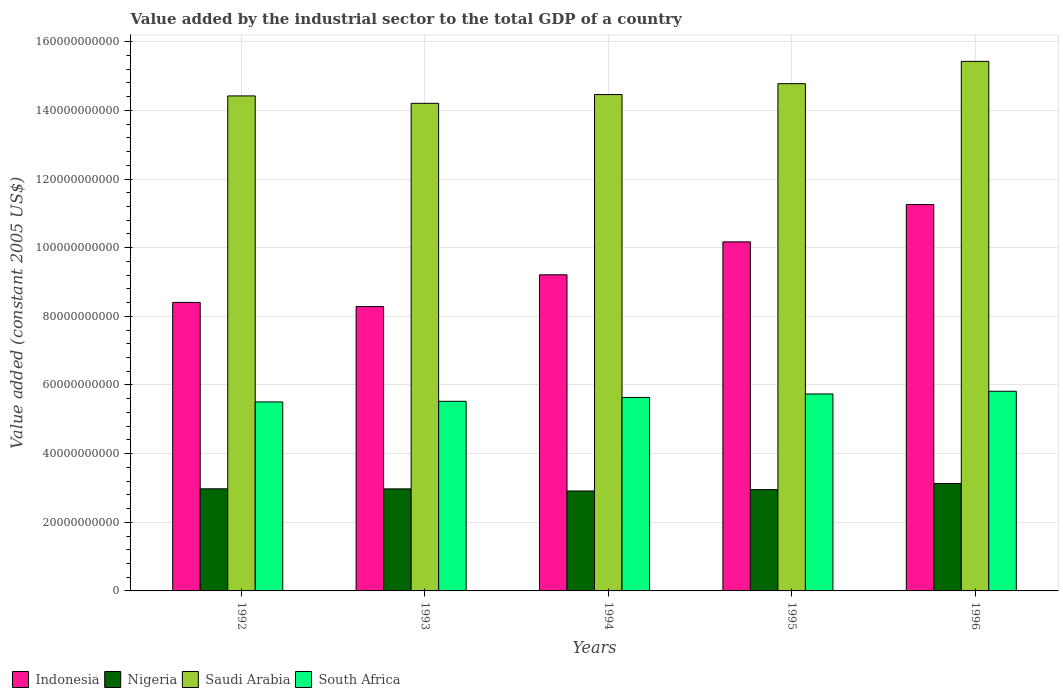How many different coloured bars are there?
Offer a terse response. 4. How many groups of bars are there?
Make the answer very short. 5. Are the number of bars per tick equal to the number of legend labels?
Provide a succinct answer. Yes. Are the number of bars on each tick of the X-axis equal?
Your answer should be very brief. Yes. In how many cases, is the number of bars for a given year not equal to the number of legend labels?
Keep it short and to the point. 0. What is the value added by the industrial sector in Indonesia in 1993?
Provide a succinct answer. 8.29e+1. Across all years, what is the maximum value added by the industrial sector in Nigeria?
Offer a terse response. 3.13e+1. Across all years, what is the minimum value added by the industrial sector in Nigeria?
Ensure brevity in your answer.  2.91e+1. In which year was the value added by the industrial sector in Saudi Arabia minimum?
Offer a terse response. 1993. What is the total value added by the industrial sector in South Africa in the graph?
Give a very brief answer. 2.82e+11. What is the difference between the value added by the industrial sector in Indonesia in 1992 and that in 1994?
Ensure brevity in your answer.  -8.05e+09. What is the difference between the value added by the industrial sector in Nigeria in 1992 and the value added by the industrial sector in Saudi Arabia in 1993?
Make the answer very short. -1.12e+11. What is the average value added by the industrial sector in Indonesia per year?
Your answer should be compact. 9.47e+1. In the year 1992, what is the difference between the value added by the industrial sector in Saudi Arabia and value added by the industrial sector in South Africa?
Your response must be concise. 8.92e+1. In how many years, is the value added by the industrial sector in South Africa greater than 44000000000 US$?
Your answer should be very brief. 5. What is the ratio of the value added by the industrial sector in Saudi Arabia in 1992 to that in 1993?
Your response must be concise. 1.02. Is the value added by the industrial sector in Indonesia in 1993 less than that in 1994?
Your answer should be compact. Yes. What is the difference between the highest and the second highest value added by the industrial sector in Indonesia?
Your response must be concise. 1.09e+1. What is the difference between the highest and the lowest value added by the industrial sector in Indonesia?
Provide a succinct answer. 2.97e+1. Is the sum of the value added by the industrial sector in South Africa in 1993 and 1994 greater than the maximum value added by the industrial sector in Nigeria across all years?
Provide a succinct answer. Yes. What does the 1st bar from the right in 1992 represents?
Give a very brief answer. South Africa. Is it the case that in every year, the sum of the value added by the industrial sector in South Africa and value added by the industrial sector in Nigeria is greater than the value added by the industrial sector in Indonesia?
Offer a very short reply. No. How many years are there in the graph?
Give a very brief answer. 5. What is the difference between two consecutive major ticks on the Y-axis?
Offer a terse response. 2.00e+1. Are the values on the major ticks of Y-axis written in scientific E-notation?
Give a very brief answer. No. Does the graph contain grids?
Your response must be concise. Yes. How many legend labels are there?
Your answer should be compact. 4. What is the title of the graph?
Offer a very short reply. Value added by the industrial sector to the total GDP of a country. What is the label or title of the Y-axis?
Make the answer very short. Value added (constant 2005 US$). What is the Value added (constant 2005 US$) in Indonesia in 1992?
Your response must be concise. 8.41e+1. What is the Value added (constant 2005 US$) of Nigeria in 1992?
Keep it short and to the point. 2.97e+1. What is the Value added (constant 2005 US$) of Saudi Arabia in 1992?
Make the answer very short. 1.44e+11. What is the Value added (constant 2005 US$) of South Africa in 1992?
Give a very brief answer. 5.51e+1. What is the Value added (constant 2005 US$) in Indonesia in 1993?
Your answer should be compact. 8.29e+1. What is the Value added (constant 2005 US$) in Nigeria in 1993?
Offer a terse response. 2.97e+1. What is the Value added (constant 2005 US$) of Saudi Arabia in 1993?
Give a very brief answer. 1.42e+11. What is the Value added (constant 2005 US$) in South Africa in 1993?
Offer a very short reply. 5.53e+1. What is the Value added (constant 2005 US$) of Indonesia in 1994?
Offer a terse response. 9.21e+1. What is the Value added (constant 2005 US$) of Nigeria in 1994?
Offer a terse response. 2.91e+1. What is the Value added (constant 2005 US$) of Saudi Arabia in 1994?
Provide a succinct answer. 1.45e+11. What is the Value added (constant 2005 US$) in South Africa in 1994?
Ensure brevity in your answer.  5.64e+1. What is the Value added (constant 2005 US$) in Indonesia in 1995?
Provide a succinct answer. 1.02e+11. What is the Value added (constant 2005 US$) in Nigeria in 1995?
Offer a terse response. 2.95e+1. What is the Value added (constant 2005 US$) of Saudi Arabia in 1995?
Offer a terse response. 1.48e+11. What is the Value added (constant 2005 US$) in South Africa in 1995?
Offer a very short reply. 5.74e+1. What is the Value added (constant 2005 US$) in Indonesia in 1996?
Your answer should be very brief. 1.13e+11. What is the Value added (constant 2005 US$) of Nigeria in 1996?
Give a very brief answer. 3.13e+1. What is the Value added (constant 2005 US$) of Saudi Arabia in 1996?
Your response must be concise. 1.54e+11. What is the Value added (constant 2005 US$) of South Africa in 1996?
Give a very brief answer. 5.82e+1. Across all years, what is the maximum Value added (constant 2005 US$) in Indonesia?
Offer a terse response. 1.13e+11. Across all years, what is the maximum Value added (constant 2005 US$) in Nigeria?
Ensure brevity in your answer.  3.13e+1. Across all years, what is the maximum Value added (constant 2005 US$) of Saudi Arabia?
Keep it short and to the point. 1.54e+11. Across all years, what is the maximum Value added (constant 2005 US$) in South Africa?
Your answer should be very brief. 5.82e+1. Across all years, what is the minimum Value added (constant 2005 US$) of Indonesia?
Your answer should be compact. 8.29e+1. Across all years, what is the minimum Value added (constant 2005 US$) in Nigeria?
Provide a short and direct response. 2.91e+1. Across all years, what is the minimum Value added (constant 2005 US$) in Saudi Arabia?
Give a very brief answer. 1.42e+11. Across all years, what is the minimum Value added (constant 2005 US$) of South Africa?
Give a very brief answer. 5.51e+1. What is the total Value added (constant 2005 US$) in Indonesia in the graph?
Offer a terse response. 4.73e+11. What is the total Value added (constant 2005 US$) of Nigeria in the graph?
Give a very brief answer. 1.49e+11. What is the total Value added (constant 2005 US$) in Saudi Arabia in the graph?
Your answer should be very brief. 7.33e+11. What is the total Value added (constant 2005 US$) of South Africa in the graph?
Keep it short and to the point. 2.82e+11. What is the difference between the Value added (constant 2005 US$) of Indonesia in 1992 and that in 1993?
Offer a very short reply. 1.21e+09. What is the difference between the Value added (constant 2005 US$) of Nigeria in 1992 and that in 1993?
Your answer should be very brief. 1.50e+07. What is the difference between the Value added (constant 2005 US$) of Saudi Arabia in 1992 and that in 1993?
Provide a short and direct response. 2.16e+09. What is the difference between the Value added (constant 2005 US$) in South Africa in 1992 and that in 1993?
Your answer should be very brief. -1.92e+08. What is the difference between the Value added (constant 2005 US$) of Indonesia in 1992 and that in 1994?
Offer a very short reply. -8.05e+09. What is the difference between the Value added (constant 2005 US$) in Nigeria in 1992 and that in 1994?
Keep it short and to the point. 6.24e+08. What is the difference between the Value added (constant 2005 US$) in Saudi Arabia in 1992 and that in 1994?
Give a very brief answer. -3.95e+08. What is the difference between the Value added (constant 2005 US$) in South Africa in 1992 and that in 1994?
Your answer should be compact. -1.31e+09. What is the difference between the Value added (constant 2005 US$) of Indonesia in 1992 and that in 1995?
Your response must be concise. -1.76e+1. What is the difference between the Value added (constant 2005 US$) in Nigeria in 1992 and that in 1995?
Your response must be concise. 2.28e+08. What is the difference between the Value added (constant 2005 US$) of Saudi Arabia in 1992 and that in 1995?
Make the answer very short. -3.56e+09. What is the difference between the Value added (constant 2005 US$) of South Africa in 1992 and that in 1995?
Ensure brevity in your answer.  -2.33e+09. What is the difference between the Value added (constant 2005 US$) in Indonesia in 1992 and that in 1996?
Provide a short and direct response. -2.85e+1. What is the difference between the Value added (constant 2005 US$) in Nigeria in 1992 and that in 1996?
Keep it short and to the point. -1.55e+09. What is the difference between the Value added (constant 2005 US$) in Saudi Arabia in 1992 and that in 1996?
Offer a terse response. -1.01e+1. What is the difference between the Value added (constant 2005 US$) of South Africa in 1992 and that in 1996?
Provide a short and direct response. -3.12e+09. What is the difference between the Value added (constant 2005 US$) in Indonesia in 1993 and that in 1994?
Ensure brevity in your answer.  -9.25e+09. What is the difference between the Value added (constant 2005 US$) of Nigeria in 1993 and that in 1994?
Offer a terse response. 6.09e+08. What is the difference between the Value added (constant 2005 US$) in Saudi Arabia in 1993 and that in 1994?
Offer a very short reply. -2.55e+09. What is the difference between the Value added (constant 2005 US$) of South Africa in 1993 and that in 1994?
Offer a very short reply. -1.12e+09. What is the difference between the Value added (constant 2005 US$) of Indonesia in 1993 and that in 1995?
Offer a terse response. -1.89e+1. What is the difference between the Value added (constant 2005 US$) in Nigeria in 1993 and that in 1995?
Offer a terse response. 2.13e+08. What is the difference between the Value added (constant 2005 US$) of Saudi Arabia in 1993 and that in 1995?
Keep it short and to the point. -5.72e+09. What is the difference between the Value added (constant 2005 US$) in South Africa in 1993 and that in 1995?
Give a very brief answer. -2.14e+09. What is the difference between the Value added (constant 2005 US$) of Indonesia in 1993 and that in 1996?
Give a very brief answer. -2.97e+1. What is the difference between the Value added (constant 2005 US$) of Nigeria in 1993 and that in 1996?
Ensure brevity in your answer.  -1.57e+09. What is the difference between the Value added (constant 2005 US$) of Saudi Arabia in 1993 and that in 1996?
Make the answer very short. -1.22e+1. What is the difference between the Value added (constant 2005 US$) in South Africa in 1993 and that in 1996?
Keep it short and to the point. -2.93e+09. What is the difference between the Value added (constant 2005 US$) of Indonesia in 1994 and that in 1995?
Offer a very short reply. -9.60e+09. What is the difference between the Value added (constant 2005 US$) of Nigeria in 1994 and that in 1995?
Give a very brief answer. -3.96e+08. What is the difference between the Value added (constant 2005 US$) of Saudi Arabia in 1994 and that in 1995?
Ensure brevity in your answer.  -3.17e+09. What is the difference between the Value added (constant 2005 US$) in South Africa in 1994 and that in 1995?
Ensure brevity in your answer.  -1.02e+09. What is the difference between the Value added (constant 2005 US$) of Indonesia in 1994 and that in 1996?
Provide a short and direct response. -2.05e+1. What is the difference between the Value added (constant 2005 US$) in Nigeria in 1994 and that in 1996?
Give a very brief answer. -2.17e+09. What is the difference between the Value added (constant 2005 US$) in Saudi Arabia in 1994 and that in 1996?
Give a very brief answer. -9.67e+09. What is the difference between the Value added (constant 2005 US$) of South Africa in 1994 and that in 1996?
Your answer should be very brief. -1.81e+09. What is the difference between the Value added (constant 2005 US$) of Indonesia in 1995 and that in 1996?
Your answer should be very brief. -1.09e+1. What is the difference between the Value added (constant 2005 US$) of Nigeria in 1995 and that in 1996?
Make the answer very short. -1.78e+09. What is the difference between the Value added (constant 2005 US$) in Saudi Arabia in 1995 and that in 1996?
Your response must be concise. -6.50e+09. What is the difference between the Value added (constant 2005 US$) in South Africa in 1995 and that in 1996?
Your answer should be very brief. -7.94e+08. What is the difference between the Value added (constant 2005 US$) in Indonesia in 1992 and the Value added (constant 2005 US$) in Nigeria in 1993?
Your answer should be very brief. 5.43e+1. What is the difference between the Value added (constant 2005 US$) of Indonesia in 1992 and the Value added (constant 2005 US$) of Saudi Arabia in 1993?
Provide a short and direct response. -5.80e+1. What is the difference between the Value added (constant 2005 US$) in Indonesia in 1992 and the Value added (constant 2005 US$) in South Africa in 1993?
Offer a terse response. 2.88e+1. What is the difference between the Value added (constant 2005 US$) of Nigeria in 1992 and the Value added (constant 2005 US$) of Saudi Arabia in 1993?
Your answer should be very brief. -1.12e+11. What is the difference between the Value added (constant 2005 US$) of Nigeria in 1992 and the Value added (constant 2005 US$) of South Africa in 1993?
Keep it short and to the point. -2.55e+1. What is the difference between the Value added (constant 2005 US$) of Saudi Arabia in 1992 and the Value added (constant 2005 US$) of South Africa in 1993?
Provide a short and direct response. 8.90e+1. What is the difference between the Value added (constant 2005 US$) of Indonesia in 1992 and the Value added (constant 2005 US$) of Nigeria in 1994?
Make the answer very short. 5.49e+1. What is the difference between the Value added (constant 2005 US$) of Indonesia in 1992 and the Value added (constant 2005 US$) of Saudi Arabia in 1994?
Offer a very short reply. -6.06e+1. What is the difference between the Value added (constant 2005 US$) in Indonesia in 1992 and the Value added (constant 2005 US$) in South Africa in 1994?
Give a very brief answer. 2.77e+1. What is the difference between the Value added (constant 2005 US$) in Nigeria in 1992 and the Value added (constant 2005 US$) in Saudi Arabia in 1994?
Your answer should be very brief. -1.15e+11. What is the difference between the Value added (constant 2005 US$) of Nigeria in 1992 and the Value added (constant 2005 US$) of South Africa in 1994?
Make the answer very short. -2.66e+1. What is the difference between the Value added (constant 2005 US$) of Saudi Arabia in 1992 and the Value added (constant 2005 US$) of South Africa in 1994?
Keep it short and to the point. 8.79e+1. What is the difference between the Value added (constant 2005 US$) in Indonesia in 1992 and the Value added (constant 2005 US$) in Nigeria in 1995?
Provide a short and direct response. 5.45e+1. What is the difference between the Value added (constant 2005 US$) of Indonesia in 1992 and the Value added (constant 2005 US$) of Saudi Arabia in 1995?
Your response must be concise. -6.37e+1. What is the difference between the Value added (constant 2005 US$) in Indonesia in 1992 and the Value added (constant 2005 US$) in South Africa in 1995?
Provide a short and direct response. 2.67e+1. What is the difference between the Value added (constant 2005 US$) in Nigeria in 1992 and the Value added (constant 2005 US$) in Saudi Arabia in 1995?
Give a very brief answer. -1.18e+11. What is the difference between the Value added (constant 2005 US$) in Nigeria in 1992 and the Value added (constant 2005 US$) in South Africa in 1995?
Ensure brevity in your answer.  -2.76e+1. What is the difference between the Value added (constant 2005 US$) of Saudi Arabia in 1992 and the Value added (constant 2005 US$) of South Africa in 1995?
Your answer should be very brief. 8.68e+1. What is the difference between the Value added (constant 2005 US$) in Indonesia in 1992 and the Value added (constant 2005 US$) in Nigeria in 1996?
Your answer should be compact. 5.28e+1. What is the difference between the Value added (constant 2005 US$) of Indonesia in 1992 and the Value added (constant 2005 US$) of Saudi Arabia in 1996?
Ensure brevity in your answer.  -7.02e+1. What is the difference between the Value added (constant 2005 US$) of Indonesia in 1992 and the Value added (constant 2005 US$) of South Africa in 1996?
Give a very brief answer. 2.59e+1. What is the difference between the Value added (constant 2005 US$) in Nigeria in 1992 and the Value added (constant 2005 US$) in Saudi Arabia in 1996?
Keep it short and to the point. -1.25e+11. What is the difference between the Value added (constant 2005 US$) of Nigeria in 1992 and the Value added (constant 2005 US$) of South Africa in 1996?
Ensure brevity in your answer.  -2.84e+1. What is the difference between the Value added (constant 2005 US$) in Saudi Arabia in 1992 and the Value added (constant 2005 US$) in South Africa in 1996?
Make the answer very short. 8.60e+1. What is the difference between the Value added (constant 2005 US$) in Indonesia in 1993 and the Value added (constant 2005 US$) in Nigeria in 1994?
Keep it short and to the point. 5.37e+1. What is the difference between the Value added (constant 2005 US$) in Indonesia in 1993 and the Value added (constant 2005 US$) in Saudi Arabia in 1994?
Your response must be concise. -6.18e+1. What is the difference between the Value added (constant 2005 US$) in Indonesia in 1993 and the Value added (constant 2005 US$) in South Africa in 1994?
Your response must be concise. 2.65e+1. What is the difference between the Value added (constant 2005 US$) of Nigeria in 1993 and the Value added (constant 2005 US$) of Saudi Arabia in 1994?
Keep it short and to the point. -1.15e+11. What is the difference between the Value added (constant 2005 US$) in Nigeria in 1993 and the Value added (constant 2005 US$) in South Africa in 1994?
Provide a short and direct response. -2.66e+1. What is the difference between the Value added (constant 2005 US$) of Saudi Arabia in 1993 and the Value added (constant 2005 US$) of South Africa in 1994?
Ensure brevity in your answer.  8.57e+1. What is the difference between the Value added (constant 2005 US$) of Indonesia in 1993 and the Value added (constant 2005 US$) of Nigeria in 1995?
Provide a succinct answer. 5.33e+1. What is the difference between the Value added (constant 2005 US$) in Indonesia in 1993 and the Value added (constant 2005 US$) in Saudi Arabia in 1995?
Keep it short and to the point. -6.49e+1. What is the difference between the Value added (constant 2005 US$) of Indonesia in 1993 and the Value added (constant 2005 US$) of South Africa in 1995?
Provide a succinct answer. 2.55e+1. What is the difference between the Value added (constant 2005 US$) in Nigeria in 1993 and the Value added (constant 2005 US$) in Saudi Arabia in 1995?
Your answer should be very brief. -1.18e+11. What is the difference between the Value added (constant 2005 US$) in Nigeria in 1993 and the Value added (constant 2005 US$) in South Africa in 1995?
Provide a succinct answer. -2.77e+1. What is the difference between the Value added (constant 2005 US$) of Saudi Arabia in 1993 and the Value added (constant 2005 US$) of South Africa in 1995?
Make the answer very short. 8.47e+1. What is the difference between the Value added (constant 2005 US$) in Indonesia in 1993 and the Value added (constant 2005 US$) in Nigeria in 1996?
Provide a short and direct response. 5.16e+1. What is the difference between the Value added (constant 2005 US$) in Indonesia in 1993 and the Value added (constant 2005 US$) in Saudi Arabia in 1996?
Give a very brief answer. -7.14e+1. What is the difference between the Value added (constant 2005 US$) of Indonesia in 1993 and the Value added (constant 2005 US$) of South Africa in 1996?
Provide a succinct answer. 2.47e+1. What is the difference between the Value added (constant 2005 US$) of Nigeria in 1993 and the Value added (constant 2005 US$) of Saudi Arabia in 1996?
Your answer should be very brief. -1.25e+11. What is the difference between the Value added (constant 2005 US$) of Nigeria in 1993 and the Value added (constant 2005 US$) of South Africa in 1996?
Provide a short and direct response. -2.84e+1. What is the difference between the Value added (constant 2005 US$) of Saudi Arabia in 1993 and the Value added (constant 2005 US$) of South Africa in 1996?
Ensure brevity in your answer.  8.39e+1. What is the difference between the Value added (constant 2005 US$) in Indonesia in 1994 and the Value added (constant 2005 US$) in Nigeria in 1995?
Offer a terse response. 6.26e+1. What is the difference between the Value added (constant 2005 US$) of Indonesia in 1994 and the Value added (constant 2005 US$) of Saudi Arabia in 1995?
Your answer should be compact. -5.57e+1. What is the difference between the Value added (constant 2005 US$) of Indonesia in 1994 and the Value added (constant 2005 US$) of South Africa in 1995?
Offer a terse response. 3.47e+1. What is the difference between the Value added (constant 2005 US$) in Nigeria in 1994 and the Value added (constant 2005 US$) in Saudi Arabia in 1995?
Make the answer very short. -1.19e+11. What is the difference between the Value added (constant 2005 US$) in Nigeria in 1994 and the Value added (constant 2005 US$) in South Africa in 1995?
Your response must be concise. -2.83e+1. What is the difference between the Value added (constant 2005 US$) in Saudi Arabia in 1994 and the Value added (constant 2005 US$) in South Africa in 1995?
Keep it short and to the point. 8.72e+1. What is the difference between the Value added (constant 2005 US$) in Indonesia in 1994 and the Value added (constant 2005 US$) in Nigeria in 1996?
Your response must be concise. 6.08e+1. What is the difference between the Value added (constant 2005 US$) of Indonesia in 1994 and the Value added (constant 2005 US$) of Saudi Arabia in 1996?
Offer a terse response. -6.22e+1. What is the difference between the Value added (constant 2005 US$) of Indonesia in 1994 and the Value added (constant 2005 US$) of South Africa in 1996?
Ensure brevity in your answer.  3.39e+1. What is the difference between the Value added (constant 2005 US$) in Nigeria in 1994 and the Value added (constant 2005 US$) in Saudi Arabia in 1996?
Your answer should be very brief. -1.25e+11. What is the difference between the Value added (constant 2005 US$) in Nigeria in 1994 and the Value added (constant 2005 US$) in South Africa in 1996?
Give a very brief answer. -2.91e+1. What is the difference between the Value added (constant 2005 US$) of Saudi Arabia in 1994 and the Value added (constant 2005 US$) of South Africa in 1996?
Ensure brevity in your answer.  8.64e+1. What is the difference between the Value added (constant 2005 US$) of Indonesia in 1995 and the Value added (constant 2005 US$) of Nigeria in 1996?
Provide a short and direct response. 7.04e+1. What is the difference between the Value added (constant 2005 US$) of Indonesia in 1995 and the Value added (constant 2005 US$) of Saudi Arabia in 1996?
Offer a very short reply. -5.26e+1. What is the difference between the Value added (constant 2005 US$) of Indonesia in 1995 and the Value added (constant 2005 US$) of South Africa in 1996?
Offer a very short reply. 4.35e+1. What is the difference between the Value added (constant 2005 US$) of Nigeria in 1995 and the Value added (constant 2005 US$) of Saudi Arabia in 1996?
Keep it short and to the point. -1.25e+11. What is the difference between the Value added (constant 2005 US$) in Nigeria in 1995 and the Value added (constant 2005 US$) in South Africa in 1996?
Provide a short and direct response. -2.87e+1. What is the difference between the Value added (constant 2005 US$) of Saudi Arabia in 1995 and the Value added (constant 2005 US$) of South Africa in 1996?
Give a very brief answer. 8.96e+1. What is the average Value added (constant 2005 US$) of Indonesia per year?
Provide a short and direct response. 9.47e+1. What is the average Value added (constant 2005 US$) of Nigeria per year?
Provide a succinct answer. 2.99e+1. What is the average Value added (constant 2005 US$) in Saudi Arabia per year?
Keep it short and to the point. 1.47e+11. What is the average Value added (constant 2005 US$) of South Africa per year?
Provide a short and direct response. 5.64e+1. In the year 1992, what is the difference between the Value added (constant 2005 US$) in Indonesia and Value added (constant 2005 US$) in Nigeria?
Your response must be concise. 5.43e+1. In the year 1992, what is the difference between the Value added (constant 2005 US$) of Indonesia and Value added (constant 2005 US$) of Saudi Arabia?
Give a very brief answer. -6.02e+1. In the year 1992, what is the difference between the Value added (constant 2005 US$) in Indonesia and Value added (constant 2005 US$) in South Africa?
Provide a short and direct response. 2.90e+1. In the year 1992, what is the difference between the Value added (constant 2005 US$) of Nigeria and Value added (constant 2005 US$) of Saudi Arabia?
Provide a succinct answer. -1.14e+11. In the year 1992, what is the difference between the Value added (constant 2005 US$) of Nigeria and Value added (constant 2005 US$) of South Africa?
Your response must be concise. -2.53e+1. In the year 1992, what is the difference between the Value added (constant 2005 US$) in Saudi Arabia and Value added (constant 2005 US$) in South Africa?
Provide a short and direct response. 8.92e+1. In the year 1993, what is the difference between the Value added (constant 2005 US$) of Indonesia and Value added (constant 2005 US$) of Nigeria?
Provide a succinct answer. 5.31e+1. In the year 1993, what is the difference between the Value added (constant 2005 US$) of Indonesia and Value added (constant 2005 US$) of Saudi Arabia?
Keep it short and to the point. -5.92e+1. In the year 1993, what is the difference between the Value added (constant 2005 US$) of Indonesia and Value added (constant 2005 US$) of South Africa?
Your answer should be compact. 2.76e+1. In the year 1993, what is the difference between the Value added (constant 2005 US$) of Nigeria and Value added (constant 2005 US$) of Saudi Arabia?
Give a very brief answer. -1.12e+11. In the year 1993, what is the difference between the Value added (constant 2005 US$) in Nigeria and Value added (constant 2005 US$) in South Africa?
Your answer should be compact. -2.55e+1. In the year 1993, what is the difference between the Value added (constant 2005 US$) of Saudi Arabia and Value added (constant 2005 US$) of South Africa?
Keep it short and to the point. 8.68e+1. In the year 1994, what is the difference between the Value added (constant 2005 US$) of Indonesia and Value added (constant 2005 US$) of Nigeria?
Provide a short and direct response. 6.30e+1. In the year 1994, what is the difference between the Value added (constant 2005 US$) in Indonesia and Value added (constant 2005 US$) in Saudi Arabia?
Offer a very short reply. -5.25e+1. In the year 1994, what is the difference between the Value added (constant 2005 US$) of Indonesia and Value added (constant 2005 US$) of South Africa?
Your answer should be compact. 3.57e+1. In the year 1994, what is the difference between the Value added (constant 2005 US$) in Nigeria and Value added (constant 2005 US$) in Saudi Arabia?
Keep it short and to the point. -1.15e+11. In the year 1994, what is the difference between the Value added (constant 2005 US$) in Nigeria and Value added (constant 2005 US$) in South Africa?
Provide a succinct answer. -2.72e+1. In the year 1994, what is the difference between the Value added (constant 2005 US$) of Saudi Arabia and Value added (constant 2005 US$) of South Africa?
Keep it short and to the point. 8.83e+1. In the year 1995, what is the difference between the Value added (constant 2005 US$) of Indonesia and Value added (constant 2005 US$) of Nigeria?
Your answer should be compact. 7.22e+1. In the year 1995, what is the difference between the Value added (constant 2005 US$) in Indonesia and Value added (constant 2005 US$) in Saudi Arabia?
Keep it short and to the point. -4.61e+1. In the year 1995, what is the difference between the Value added (constant 2005 US$) in Indonesia and Value added (constant 2005 US$) in South Africa?
Make the answer very short. 4.43e+1. In the year 1995, what is the difference between the Value added (constant 2005 US$) of Nigeria and Value added (constant 2005 US$) of Saudi Arabia?
Your response must be concise. -1.18e+11. In the year 1995, what is the difference between the Value added (constant 2005 US$) in Nigeria and Value added (constant 2005 US$) in South Africa?
Offer a terse response. -2.79e+1. In the year 1995, what is the difference between the Value added (constant 2005 US$) in Saudi Arabia and Value added (constant 2005 US$) in South Africa?
Keep it short and to the point. 9.04e+1. In the year 1996, what is the difference between the Value added (constant 2005 US$) of Indonesia and Value added (constant 2005 US$) of Nigeria?
Keep it short and to the point. 8.13e+1. In the year 1996, what is the difference between the Value added (constant 2005 US$) of Indonesia and Value added (constant 2005 US$) of Saudi Arabia?
Provide a short and direct response. -4.17e+1. In the year 1996, what is the difference between the Value added (constant 2005 US$) in Indonesia and Value added (constant 2005 US$) in South Africa?
Make the answer very short. 5.44e+1. In the year 1996, what is the difference between the Value added (constant 2005 US$) of Nigeria and Value added (constant 2005 US$) of Saudi Arabia?
Your answer should be very brief. -1.23e+11. In the year 1996, what is the difference between the Value added (constant 2005 US$) in Nigeria and Value added (constant 2005 US$) in South Africa?
Ensure brevity in your answer.  -2.69e+1. In the year 1996, what is the difference between the Value added (constant 2005 US$) in Saudi Arabia and Value added (constant 2005 US$) in South Africa?
Offer a very short reply. 9.61e+1. What is the ratio of the Value added (constant 2005 US$) of Indonesia in 1992 to that in 1993?
Ensure brevity in your answer.  1.01. What is the ratio of the Value added (constant 2005 US$) in Saudi Arabia in 1992 to that in 1993?
Offer a very short reply. 1.02. What is the ratio of the Value added (constant 2005 US$) in South Africa in 1992 to that in 1993?
Provide a succinct answer. 1. What is the ratio of the Value added (constant 2005 US$) in Indonesia in 1992 to that in 1994?
Provide a short and direct response. 0.91. What is the ratio of the Value added (constant 2005 US$) in Nigeria in 1992 to that in 1994?
Ensure brevity in your answer.  1.02. What is the ratio of the Value added (constant 2005 US$) in South Africa in 1992 to that in 1994?
Give a very brief answer. 0.98. What is the ratio of the Value added (constant 2005 US$) in Indonesia in 1992 to that in 1995?
Your answer should be compact. 0.83. What is the ratio of the Value added (constant 2005 US$) in Nigeria in 1992 to that in 1995?
Make the answer very short. 1.01. What is the ratio of the Value added (constant 2005 US$) of Saudi Arabia in 1992 to that in 1995?
Make the answer very short. 0.98. What is the ratio of the Value added (constant 2005 US$) of South Africa in 1992 to that in 1995?
Your answer should be very brief. 0.96. What is the ratio of the Value added (constant 2005 US$) of Indonesia in 1992 to that in 1996?
Provide a succinct answer. 0.75. What is the ratio of the Value added (constant 2005 US$) of Nigeria in 1992 to that in 1996?
Offer a terse response. 0.95. What is the ratio of the Value added (constant 2005 US$) of Saudi Arabia in 1992 to that in 1996?
Your response must be concise. 0.93. What is the ratio of the Value added (constant 2005 US$) in South Africa in 1992 to that in 1996?
Ensure brevity in your answer.  0.95. What is the ratio of the Value added (constant 2005 US$) in Indonesia in 1993 to that in 1994?
Keep it short and to the point. 0.9. What is the ratio of the Value added (constant 2005 US$) in Nigeria in 1993 to that in 1994?
Your response must be concise. 1.02. What is the ratio of the Value added (constant 2005 US$) of Saudi Arabia in 1993 to that in 1994?
Offer a terse response. 0.98. What is the ratio of the Value added (constant 2005 US$) in South Africa in 1993 to that in 1994?
Ensure brevity in your answer.  0.98. What is the ratio of the Value added (constant 2005 US$) in Indonesia in 1993 to that in 1995?
Make the answer very short. 0.81. What is the ratio of the Value added (constant 2005 US$) of Nigeria in 1993 to that in 1995?
Keep it short and to the point. 1.01. What is the ratio of the Value added (constant 2005 US$) in Saudi Arabia in 1993 to that in 1995?
Your answer should be compact. 0.96. What is the ratio of the Value added (constant 2005 US$) in South Africa in 1993 to that in 1995?
Ensure brevity in your answer.  0.96. What is the ratio of the Value added (constant 2005 US$) of Indonesia in 1993 to that in 1996?
Your response must be concise. 0.74. What is the ratio of the Value added (constant 2005 US$) of Nigeria in 1993 to that in 1996?
Provide a short and direct response. 0.95. What is the ratio of the Value added (constant 2005 US$) of Saudi Arabia in 1993 to that in 1996?
Ensure brevity in your answer.  0.92. What is the ratio of the Value added (constant 2005 US$) of South Africa in 1993 to that in 1996?
Your response must be concise. 0.95. What is the ratio of the Value added (constant 2005 US$) in Indonesia in 1994 to that in 1995?
Offer a terse response. 0.91. What is the ratio of the Value added (constant 2005 US$) in Nigeria in 1994 to that in 1995?
Ensure brevity in your answer.  0.99. What is the ratio of the Value added (constant 2005 US$) in Saudi Arabia in 1994 to that in 1995?
Give a very brief answer. 0.98. What is the ratio of the Value added (constant 2005 US$) of South Africa in 1994 to that in 1995?
Provide a succinct answer. 0.98. What is the ratio of the Value added (constant 2005 US$) of Indonesia in 1994 to that in 1996?
Make the answer very short. 0.82. What is the ratio of the Value added (constant 2005 US$) in Nigeria in 1994 to that in 1996?
Provide a succinct answer. 0.93. What is the ratio of the Value added (constant 2005 US$) of Saudi Arabia in 1994 to that in 1996?
Your response must be concise. 0.94. What is the ratio of the Value added (constant 2005 US$) in South Africa in 1994 to that in 1996?
Keep it short and to the point. 0.97. What is the ratio of the Value added (constant 2005 US$) of Indonesia in 1995 to that in 1996?
Ensure brevity in your answer.  0.9. What is the ratio of the Value added (constant 2005 US$) of Nigeria in 1995 to that in 1996?
Your response must be concise. 0.94. What is the ratio of the Value added (constant 2005 US$) of Saudi Arabia in 1995 to that in 1996?
Offer a terse response. 0.96. What is the ratio of the Value added (constant 2005 US$) in South Africa in 1995 to that in 1996?
Provide a succinct answer. 0.99. What is the difference between the highest and the second highest Value added (constant 2005 US$) of Indonesia?
Your answer should be very brief. 1.09e+1. What is the difference between the highest and the second highest Value added (constant 2005 US$) of Nigeria?
Your answer should be compact. 1.55e+09. What is the difference between the highest and the second highest Value added (constant 2005 US$) in Saudi Arabia?
Your answer should be very brief. 6.50e+09. What is the difference between the highest and the second highest Value added (constant 2005 US$) of South Africa?
Provide a short and direct response. 7.94e+08. What is the difference between the highest and the lowest Value added (constant 2005 US$) in Indonesia?
Offer a very short reply. 2.97e+1. What is the difference between the highest and the lowest Value added (constant 2005 US$) of Nigeria?
Offer a very short reply. 2.17e+09. What is the difference between the highest and the lowest Value added (constant 2005 US$) in Saudi Arabia?
Offer a terse response. 1.22e+1. What is the difference between the highest and the lowest Value added (constant 2005 US$) in South Africa?
Ensure brevity in your answer.  3.12e+09. 